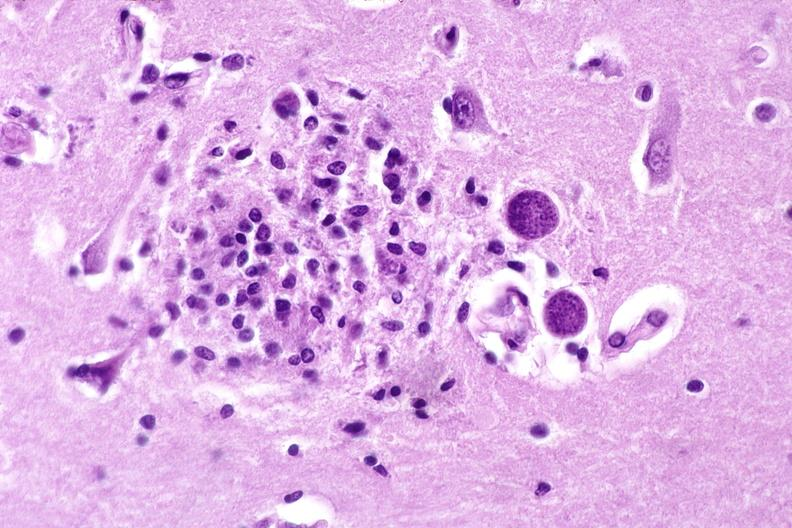where is this?
Answer the question using a single word or phrase. Nervous 